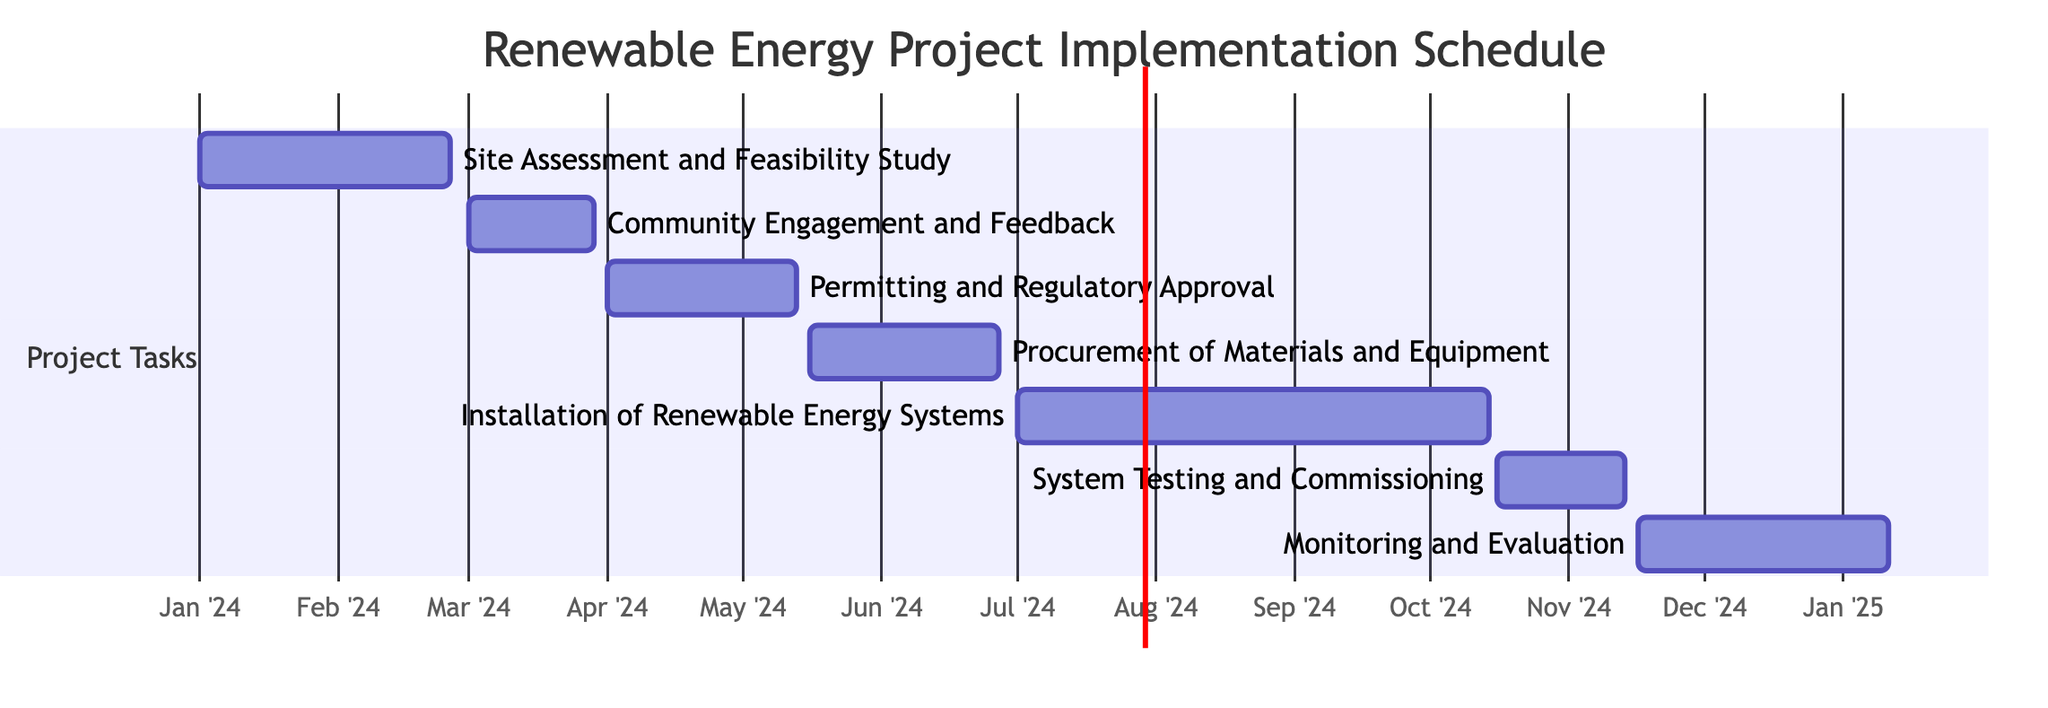what is the duration of the "Site Assessment and Feasibility Study"? The diagram indicates that the "Site Assessment and Feasibility Study" task has a duration of 8 weeks, which is directly provided in the data.
Answer: 8 weeks when does the "Community Engagement and Feedback" task start? According to the Gantt chart, the "Community Engagement and Feedback" task starts on March 1, 2024, as noted in the start date section of the task.
Answer: March 1, 2024 what tasks overlap with "Installation of Renewable Energy Systems"? By examining the timeline on the Gantt chart, the tasks that overlap with "Installation of Renewable Energy Systems" are "Permitting and Regulatory Approval", "Procurement of Materials and Equipment", and "System Testing and Commissioning". These tasks have their start and end dates within the duration of the installation task.
Answer: Permitting and Regulatory Approval, Procurement of Materials and Equipment, System Testing and Commissioning how long does the "Monitoring and Evaluation" phase last? The Gantt chart specifies that the "Monitoring and Evaluation" phase runs for 8 weeks, as highlighted in the duration data for that task.
Answer: 8 weeks which task has the longest duration? By reviewing the durations of all tasks in the Gantt chart, "Installation of Renewable Energy Systems" has the longest duration of 15 weeks.
Answer: Installation of Renewable Energy Systems what is the end date for "System Testing and Commissioning"? The end date for the "System Testing and Commissioning" task can be found on the Gantt chart, indicated as November 15, 2024, which is derived from the specific timeline associated with that task.
Answer: November 15, 2024 how many tasks are scheduled after "Procurement of Materials and Equipment"? The Gantt chart shows that after "Procurement of Materials and Equipment", there are two tasks scheduled: "Installation of Renewable Energy Systems" and "System Testing and Commissioning". Therefore, there are two tasks following it.
Answer: 2 tasks what is the total number of tasks in the Gantt chart? By inspecting the Gantt chart, it can be seen that there are a total of 7 tasks listed under the project schedule, confirming the overall structure of the schedule.
Answer: 7 tasks 